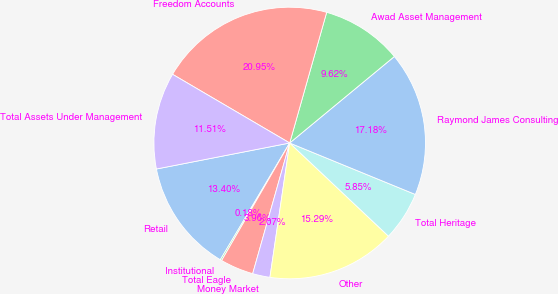Convert chart to OTSL. <chart><loc_0><loc_0><loc_500><loc_500><pie_chart><fcel>Retail<fcel>Institutional<fcel>Total Eagle<fcel>Money Market<fcel>Other<fcel>Total Heritage<fcel>Raymond James Consulting<fcel>Awad Asset Management<fcel>Freedom Accounts<fcel>Total Assets Under Management<nl><fcel>13.4%<fcel>0.18%<fcel>3.96%<fcel>2.07%<fcel>15.29%<fcel>5.85%<fcel>17.18%<fcel>9.62%<fcel>20.95%<fcel>11.51%<nl></chart> 